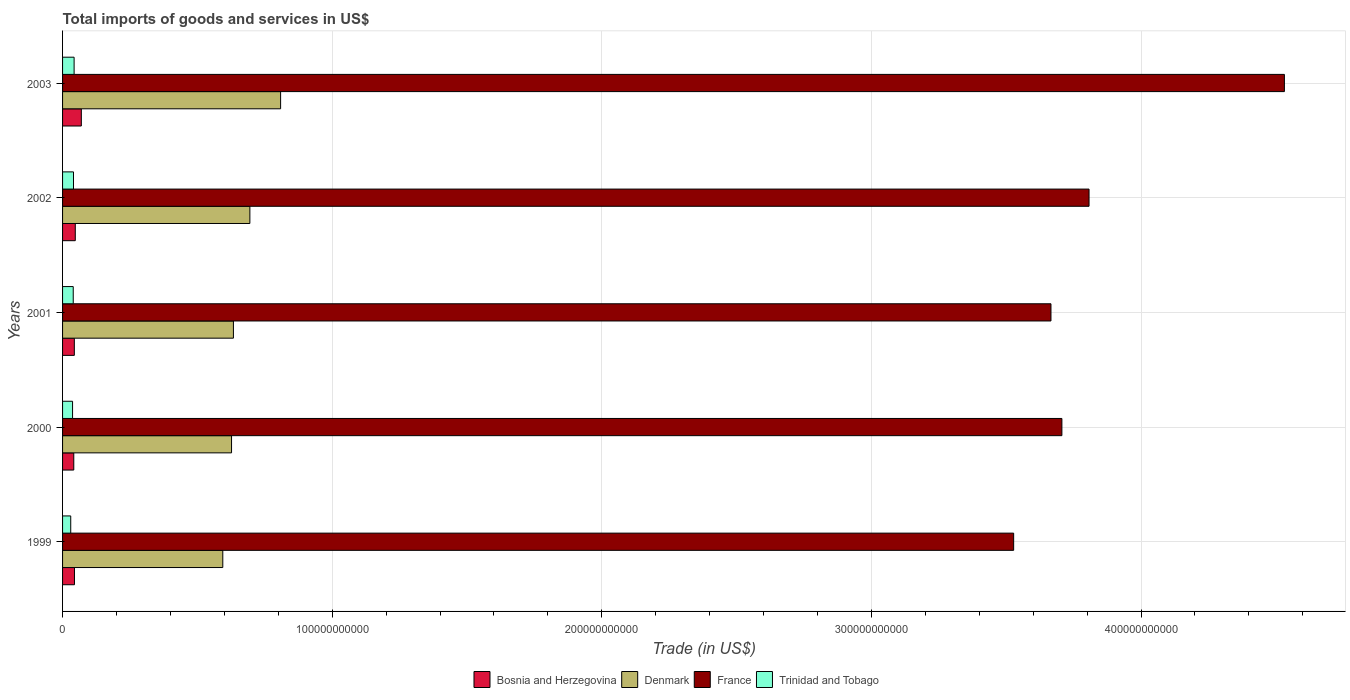How many different coloured bars are there?
Ensure brevity in your answer.  4. How many groups of bars are there?
Provide a succinct answer. 5. Are the number of bars per tick equal to the number of legend labels?
Give a very brief answer. Yes. Are the number of bars on each tick of the Y-axis equal?
Your answer should be very brief. Yes. How many bars are there on the 4th tick from the bottom?
Provide a succinct answer. 4. What is the label of the 2nd group of bars from the top?
Offer a very short reply. 2002. In how many cases, is the number of bars for a given year not equal to the number of legend labels?
Your answer should be very brief. 0. What is the total imports of goods and services in Bosnia and Herzegovina in 2000?
Your answer should be very brief. 4.16e+09. Across all years, what is the maximum total imports of goods and services in Bosnia and Herzegovina?
Ensure brevity in your answer.  6.96e+09. Across all years, what is the minimum total imports of goods and services in Denmark?
Offer a terse response. 5.94e+1. What is the total total imports of goods and services in Trinidad and Tobago in the graph?
Offer a terse response. 1.90e+1. What is the difference between the total imports of goods and services in Denmark in 2000 and that in 2002?
Ensure brevity in your answer.  -6.80e+09. What is the difference between the total imports of goods and services in France in 2000 and the total imports of goods and services in Trinidad and Tobago in 1999?
Make the answer very short. 3.68e+11. What is the average total imports of goods and services in Trinidad and Tobago per year?
Offer a terse response. 3.81e+09. In the year 2001, what is the difference between the total imports of goods and services in Bosnia and Herzegovina and total imports of goods and services in France?
Provide a succinct answer. -3.62e+11. What is the ratio of the total imports of goods and services in France in 1999 to that in 2002?
Provide a short and direct response. 0.93. Is the total imports of goods and services in France in 1999 less than that in 2002?
Offer a very short reply. Yes. What is the difference between the highest and the second highest total imports of goods and services in Trinidad and Tobago?
Offer a terse response. 2.28e+08. What is the difference between the highest and the lowest total imports of goods and services in Trinidad and Tobago?
Offer a very short reply. 1.26e+09. Is the sum of the total imports of goods and services in Denmark in 2000 and 2003 greater than the maximum total imports of goods and services in France across all years?
Provide a short and direct response. No. Is it the case that in every year, the sum of the total imports of goods and services in Bosnia and Herzegovina and total imports of goods and services in France is greater than the sum of total imports of goods and services in Trinidad and Tobago and total imports of goods and services in Denmark?
Give a very brief answer. No. What does the 1st bar from the top in 2003 represents?
Your answer should be compact. Trinidad and Tobago. What does the 4th bar from the bottom in 2003 represents?
Your answer should be very brief. Trinidad and Tobago. Is it the case that in every year, the sum of the total imports of goods and services in Bosnia and Herzegovina and total imports of goods and services in France is greater than the total imports of goods and services in Denmark?
Keep it short and to the point. Yes. How many bars are there?
Your answer should be compact. 20. Are all the bars in the graph horizontal?
Make the answer very short. Yes. What is the difference between two consecutive major ticks on the X-axis?
Your answer should be very brief. 1.00e+11. Are the values on the major ticks of X-axis written in scientific E-notation?
Keep it short and to the point. No. Does the graph contain grids?
Your response must be concise. Yes. Where does the legend appear in the graph?
Ensure brevity in your answer.  Bottom center. How many legend labels are there?
Provide a succinct answer. 4. How are the legend labels stacked?
Make the answer very short. Horizontal. What is the title of the graph?
Your answer should be very brief. Total imports of goods and services in US$. Does "Lower middle income" appear as one of the legend labels in the graph?
Give a very brief answer. No. What is the label or title of the X-axis?
Offer a terse response. Trade (in US$). What is the label or title of the Y-axis?
Keep it short and to the point. Years. What is the Trade (in US$) of Bosnia and Herzegovina in 1999?
Your answer should be very brief. 4.41e+09. What is the Trade (in US$) of Denmark in 1999?
Ensure brevity in your answer.  5.94e+1. What is the Trade (in US$) of France in 1999?
Offer a terse response. 3.53e+11. What is the Trade (in US$) in Trinidad and Tobago in 1999?
Offer a very short reply. 3.03e+09. What is the Trade (in US$) of Bosnia and Herzegovina in 2000?
Ensure brevity in your answer.  4.16e+09. What is the Trade (in US$) of Denmark in 2000?
Keep it short and to the point. 6.27e+1. What is the Trade (in US$) of France in 2000?
Ensure brevity in your answer.  3.71e+11. What is the Trade (in US$) of Trinidad and Tobago in 2000?
Offer a terse response. 3.71e+09. What is the Trade (in US$) in Bosnia and Herzegovina in 2001?
Keep it short and to the point. 4.37e+09. What is the Trade (in US$) of Denmark in 2001?
Provide a short and direct response. 6.34e+1. What is the Trade (in US$) in France in 2001?
Give a very brief answer. 3.67e+11. What is the Trade (in US$) in Trinidad and Tobago in 2001?
Provide a short and direct response. 3.96e+09. What is the Trade (in US$) in Bosnia and Herzegovina in 2002?
Offer a terse response. 4.72e+09. What is the Trade (in US$) in Denmark in 2002?
Offer a very short reply. 6.95e+1. What is the Trade (in US$) of France in 2002?
Offer a very short reply. 3.81e+11. What is the Trade (in US$) in Trinidad and Tobago in 2002?
Provide a short and direct response. 4.06e+09. What is the Trade (in US$) in Bosnia and Herzegovina in 2003?
Provide a succinct answer. 6.96e+09. What is the Trade (in US$) in Denmark in 2003?
Your response must be concise. 8.09e+1. What is the Trade (in US$) of France in 2003?
Provide a succinct answer. 4.53e+11. What is the Trade (in US$) of Trinidad and Tobago in 2003?
Provide a succinct answer. 4.28e+09. Across all years, what is the maximum Trade (in US$) in Bosnia and Herzegovina?
Keep it short and to the point. 6.96e+09. Across all years, what is the maximum Trade (in US$) in Denmark?
Make the answer very short. 8.09e+1. Across all years, what is the maximum Trade (in US$) of France?
Your response must be concise. 4.53e+11. Across all years, what is the maximum Trade (in US$) of Trinidad and Tobago?
Ensure brevity in your answer.  4.28e+09. Across all years, what is the minimum Trade (in US$) of Bosnia and Herzegovina?
Provide a short and direct response. 4.16e+09. Across all years, what is the minimum Trade (in US$) of Denmark?
Make the answer very short. 5.94e+1. Across all years, what is the minimum Trade (in US$) in France?
Provide a short and direct response. 3.53e+11. Across all years, what is the minimum Trade (in US$) in Trinidad and Tobago?
Your answer should be very brief. 3.03e+09. What is the total Trade (in US$) in Bosnia and Herzegovina in the graph?
Your response must be concise. 2.46e+1. What is the total Trade (in US$) in Denmark in the graph?
Provide a short and direct response. 3.36e+11. What is the total Trade (in US$) in France in the graph?
Ensure brevity in your answer.  1.92e+12. What is the total Trade (in US$) of Trinidad and Tobago in the graph?
Provide a succinct answer. 1.90e+1. What is the difference between the Trade (in US$) in Bosnia and Herzegovina in 1999 and that in 2000?
Your answer should be very brief. 2.56e+08. What is the difference between the Trade (in US$) of Denmark in 1999 and that in 2000?
Your response must be concise. -3.24e+09. What is the difference between the Trade (in US$) of France in 1999 and that in 2000?
Your answer should be compact. -1.79e+1. What is the difference between the Trade (in US$) of Trinidad and Tobago in 1999 and that in 2000?
Your answer should be compact. -6.83e+08. What is the difference between the Trade (in US$) of Bosnia and Herzegovina in 1999 and that in 2001?
Give a very brief answer. 4.79e+07. What is the difference between the Trade (in US$) of Denmark in 1999 and that in 2001?
Make the answer very short. -3.94e+09. What is the difference between the Trade (in US$) in France in 1999 and that in 2001?
Offer a very short reply. -1.38e+1. What is the difference between the Trade (in US$) in Trinidad and Tobago in 1999 and that in 2001?
Your response must be concise. -9.30e+08. What is the difference between the Trade (in US$) of Bosnia and Herzegovina in 1999 and that in 2002?
Ensure brevity in your answer.  -3.05e+08. What is the difference between the Trade (in US$) in Denmark in 1999 and that in 2002?
Ensure brevity in your answer.  -1.00e+1. What is the difference between the Trade (in US$) in France in 1999 and that in 2002?
Provide a short and direct response. -2.80e+1. What is the difference between the Trade (in US$) of Trinidad and Tobago in 1999 and that in 2002?
Offer a very short reply. -1.03e+09. What is the difference between the Trade (in US$) of Bosnia and Herzegovina in 1999 and that in 2003?
Offer a very short reply. -2.55e+09. What is the difference between the Trade (in US$) of Denmark in 1999 and that in 2003?
Provide a succinct answer. -2.14e+1. What is the difference between the Trade (in US$) in France in 1999 and that in 2003?
Offer a very short reply. -1.00e+11. What is the difference between the Trade (in US$) in Trinidad and Tobago in 1999 and that in 2003?
Provide a succinct answer. -1.26e+09. What is the difference between the Trade (in US$) in Bosnia and Herzegovina in 2000 and that in 2001?
Provide a short and direct response. -2.08e+08. What is the difference between the Trade (in US$) in Denmark in 2000 and that in 2001?
Give a very brief answer. -6.96e+08. What is the difference between the Trade (in US$) of France in 2000 and that in 2001?
Provide a short and direct response. 4.06e+09. What is the difference between the Trade (in US$) in Trinidad and Tobago in 2000 and that in 2001?
Offer a terse response. -2.47e+08. What is the difference between the Trade (in US$) of Bosnia and Herzegovina in 2000 and that in 2002?
Keep it short and to the point. -5.61e+08. What is the difference between the Trade (in US$) of Denmark in 2000 and that in 2002?
Your response must be concise. -6.80e+09. What is the difference between the Trade (in US$) of France in 2000 and that in 2002?
Your answer should be very brief. -1.01e+1. What is the difference between the Trade (in US$) in Trinidad and Tobago in 2000 and that in 2002?
Ensure brevity in your answer.  -3.45e+08. What is the difference between the Trade (in US$) of Bosnia and Herzegovina in 2000 and that in 2003?
Ensure brevity in your answer.  -2.80e+09. What is the difference between the Trade (in US$) in Denmark in 2000 and that in 2003?
Your answer should be very brief. -1.82e+1. What is the difference between the Trade (in US$) in France in 2000 and that in 2003?
Offer a very short reply. -8.25e+1. What is the difference between the Trade (in US$) of Trinidad and Tobago in 2000 and that in 2003?
Provide a short and direct response. -5.74e+08. What is the difference between the Trade (in US$) of Bosnia and Herzegovina in 2001 and that in 2002?
Give a very brief answer. -3.53e+08. What is the difference between the Trade (in US$) in Denmark in 2001 and that in 2002?
Make the answer very short. -6.10e+09. What is the difference between the Trade (in US$) in France in 2001 and that in 2002?
Keep it short and to the point. -1.41e+1. What is the difference between the Trade (in US$) of Trinidad and Tobago in 2001 and that in 2002?
Offer a terse response. -9.82e+07. What is the difference between the Trade (in US$) in Bosnia and Herzegovina in 2001 and that in 2003?
Your answer should be very brief. -2.60e+09. What is the difference between the Trade (in US$) in Denmark in 2001 and that in 2003?
Provide a short and direct response. -1.75e+1. What is the difference between the Trade (in US$) in France in 2001 and that in 2003?
Make the answer very short. -8.66e+1. What is the difference between the Trade (in US$) in Trinidad and Tobago in 2001 and that in 2003?
Provide a succinct answer. -3.26e+08. What is the difference between the Trade (in US$) of Bosnia and Herzegovina in 2002 and that in 2003?
Provide a short and direct response. -2.24e+09. What is the difference between the Trade (in US$) of Denmark in 2002 and that in 2003?
Your answer should be very brief. -1.14e+1. What is the difference between the Trade (in US$) of France in 2002 and that in 2003?
Give a very brief answer. -7.25e+1. What is the difference between the Trade (in US$) in Trinidad and Tobago in 2002 and that in 2003?
Give a very brief answer. -2.28e+08. What is the difference between the Trade (in US$) in Bosnia and Herzegovina in 1999 and the Trade (in US$) in Denmark in 2000?
Ensure brevity in your answer.  -5.83e+1. What is the difference between the Trade (in US$) in Bosnia and Herzegovina in 1999 and the Trade (in US$) in France in 2000?
Your answer should be compact. -3.66e+11. What is the difference between the Trade (in US$) in Bosnia and Herzegovina in 1999 and the Trade (in US$) in Trinidad and Tobago in 2000?
Give a very brief answer. 7.03e+08. What is the difference between the Trade (in US$) in Denmark in 1999 and the Trade (in US$) in France in 2000?
Make the answer very short. -3.11e+11. What is the difference between the Trade (in US$) of Denmark in 1999 and the Trade (in US$) of Trinidad and Tobago in 2000?
Your answer should be very brief. 5.57e+1. What is the difference between the Trade (in US$) of France in 1999 and the Trade (in US$) of Trinidad and Tobago in 2000?
Give a very brief answer. 3.49e+11. What is the difference between the Trade (in US$) in Bosnia and Herzegovina in 1999 and the Trade (in US$) in Denmark in 2001?
Ensure brevity in your answer.  -5.90e+1. What is the difference between the Trade (in US$) of Bosnia and Herzegovina in 1999 and the Trade (in US$) of France in 2001?
Ensure brevity in your answer.  -3.62e+11. What is the difference between the Trade (in US$) in Bosnia and Herzegovina in 1999 and the Trade (in US$) in Trinidad and Tobago in 2001?
Make the answer very short. 4.56e+08. What is the difference between the Trade (in US$) in Denmark in 1999 and the Trade (in US$) in France in 2001?
Ensure brevity in your answer.  -3.07e+11. What is the difference between the Trade (in US$) in Denmark in 1999 and the Trade (in US$) in Trinidad and Tobago in 2001?
Provide a succinct answer. 5.55e+1. What is the difference between the Trade (in US$) in France in 1999 and the Trade (in US$) in Trinidad and Tobago in 2001?
Give a very brief answer. 3.49e+11. What is the difference between the Trade (in US$) of Bosnia and Herzegovina in 1999 and the Trade (in US$) of Denmark in 2002?
Ensure brevity in your answer.  -6.51e+1. What is the difference between the Trade (in US$) of Bosnia and Herzegovina in 1999 and the Trade (in US$) of France in 2002?
Keep it short and to the point. -3.76e+11. What is the difference between the Trade (in US$) in Bosnia and Herzegovina in 1999 and the Trade (in US$) in Trinidad and Tobago in 2002?
Offer a terse response. 3.58e+08. What is the difference between the Trade (in US$) of Denmark in 1999 and the Trade (in US$) of France in 2002?
Your answer should be compact. -3.21e+11. What is the difference between the Trade (in US$) of Denmark in 1999 and the Trade (in US$) of Trinidad and Tobago in 2002?
Offer a very short reply. 5.54e+1. What is the difference between the Trade (in US$) in France in 1999 and the Trade (in US$) in Trinidad and Tobago in 2002?
Provide a short and direct response. 3.49e+11. What is the difference between the Trade (in US$) in Bosnia and Herzegovina in 1999 and the Trade (in US$) in Denmark in 2003?
Give a very brief answer. -7.65e+1. What is the difference between the Trade (in US$) in Bosnia and Herzegovina in 1999 and the Trade (in US$) in France in 2003?
Provide a succinct answer. -4.49e+11. What is the difference between the Trade (in US$) in Bosnia and Herzegovina in 1999 and the Trade (in US$) in Trinidad and Tobago in 2003?
Your answer should be very brief. 1.30e+08. What is the difference between the Trade (in US$) of Denmark in 1999 and the Trade (in US$) of France in 2003?
Provide a succinct answer. -3.94e+11. What is the difference between the Trade (in US$) of Denmark in 1999 and the Trade (in US$) of Trinidad and Tobago in 2003?
Provide a succinct answer. 5.51e+1. What is the difference between the Trade (in US$) of France in 1999 and the Trade (in US$) of Trinidad and Tobago in 2003?
Offer a very short reply. 3.48e+11. What is the difference between the Trade (in US$) of Bosnia and Herzegovina in 2000 and the Trade (in US$) of Denmark in 2001?
Keep it short and to the point. -5.92e+1. What is the difference between the Trade (in US$) in Bosnia and Herzegovina in 2000 and the Trade (in US$) in France in 2001?
Ensure brevity in your answer.  -3.62e+11. What is the difference between the Trade (in US$) of Bosnia and Herzegovina in 2000 and the Trade (in US$) of Trinidad and Tobago in 2001?
Provide a succinct answer. 2.00e+08. What is the difference between the Trade (in US$) in Denmark in 2000 and the Trade (in US$) in France in 2001?
Your response must be concise. -3.04e+11. What is the difference between the Trade (in US$) in Denmark in 2000 and the Trade (in US$) in Trinidad and Tobago in 2001?
Offer a terse response. 5.87e+1. What is the difference between the Trade (in US$) in France in 2000 and the Trade (in US$) in Trinidad and Tobago in 2001?
Your answer should be very brief. 3.67e+11. What is the difference between the Trade (in US$) in Bosnia and Herzegovina in 2000 and the Trade (in US$) in Denmark in 2002?
Ensure brevity in your answer.  -6.53e+1. What is the difference between the Trade (in US$) of Bosnia and Herzegovina in 2000 and the Trade (in US$) of France in 2002?
Your response must be concise. -3.77e+11. What is the difference between the Trade (in US$) of Bosnia and Herzegovina in 2000 and the Trade (in US$) of Trinidad and Tobago in 2002?
Provide a short and direct response. 1.02e+08. What is the difference between the Trade (in US$) in Denmark in 2000 and the Trade (in US$) in France in 2002?
Make the answer very short. -3.18e+11. What is the difference between the Trade (in US$) of Denmark in 2000 and the Trade (in US$) of Trinidad and Tobago in 2002?
Provide a succinct answer. 5.86e+1. What is the difference between the Trade (in US$) of France in 2000 and the Trade (in US$) of Trinidad and Tobago in 2002?
Offer a very short reply. 3.67e+11. What is the difference between the Trade (in US$) of Bosnia and Herzegovina in 2000 and the Trade (in US$) of Denmark in 2003?
Provide a succinct answer. -7.67e+1. What is the difference between the Trade (in US$) of Bosnia and Herzegovina in 2000 and the Trade (in US$) of France in 2003?
Provide a succinct answer. -4.49e+11. What is the difference between the Trade (in US$) of Bosnia and Herzegovina in 2000 and the Trade (in US$) of Trinidad and Tobago in 2003?
Your answer should be compact. -1.26e+08. What is the difference between the Trade (in US$) in Denmark in 2000 and the Trade (in US$) in France in 2003?
Provide a succinct answer. -3.91e+11. What is the difference between the Trade (in US$) of Denmark in 2000 and the Trade (in US$) of Trinidad and Tobago in 2003?
Your answer should be compact. 5.84e+1. What is the difference between the Trade (in US$) in France in 2000 and the Trade (in US$) in Trinidad and Tobago in 2003?
Give a very brief answer. 3.66e+11. What is the difference between the Trade (in US$) of Bosnia and Herzegovina in 2001 and the Trade (in US$) of Denmark in 2002?
Your answer should be compact. -6.51e+1. What is the difference between the Trade (in US$) of Bosnia and Herzegovina in 2001 and the Trade (in US$) of France in 2002?
Keep it short and to the point. -3.76e+11. What is the difference between the Trade (in US$) of Bosnia and Herzegovina in 2001 and the Trade (in US$) of Trinidad and Tobago in 2002?
Give a very brief answer. 3.10e+08. What is the difference between the Trade (in US$) in Denmark in 2001 and the Trade (in US$) in France in 2002?
Provide a succinct answer. -3.17e+11. What is the difference between the Trade (in US$) in Denmark in 2001 and the Trade (in US$) in Trinidad and Tobago in 2002?
Ensure brevity in your answer.  5.93e+1. What is the difference between the Trade (in US$) of France in 2001 and the Trade (in US$) of Trinidad and Tobago in 2002?
Keep it short and to the point. 3.63e+11. What is the difference between the Trade (in US$) in Bosnia and Herzegovina in 2001 and the Trade (in US$) in Denmark in 2003?
Your response must be concise. -7.65e+1. What is the difference between the Trade (in US$) in Bosnia and Herzegovina in 2001 and the Trade (in US$) in France in 2003?
Offer a very short reply. -4.49e+11. What is the difference between the Trade (in US$) of Bosnia and Herzegovina in 2001 and the Trade (in US$) of Trinidad and Tobago in 2003?
Your answer should be very brief. 8.17e+07. What is the difference between the Trade (in US$) in Denmark in 2001 and the Trade (in US$) in France in 2003?
Keep it short and to the point. -3.90e+11. What is the difference between the Trade (in US$) in Denmark in 2001 and the Trade (in US$) in Trinidad and Tobago in 2003?
Provide a succinct answer. 5.91e+1. What is the difference between the Trade (in US$) in France in 2001 and the Trade (in US$) in Trinidad and Tobago in 2003?
Ensure brevity in your answer.  3.62e+11. What is the difference between the Trade (in US$) of Bosnia and Herzegovina in 2002 and the Trade (in US$) of Denmark in 2003?
Ensure brevity in your answer.  -7.62e+1. What is the difference between the Trade (in US$) in Bosnia and Herzegovina in 2002 and the Trade (in US$) in France in 2003?
Your answer should be compact. -4.48e+11. What is the difference between the Trade (in US$) of Bosnia and Herzegovina in 2002 and the Trade (in US$) of Trinidad and Tobago in 2003?
Provide a short and direct response. 4.34e+08. What is the difference between the Trade (in US$) in Denmark in 2002 and the Trade (in US$) in France in 2003?
Offer a terse response. -3.84e+11. What is the difference between the Trade (in US$) of Denmark in 2002 and the Trade (in US$) of Trinidad and Tobago in 2003?
Your response must be concise. 6.52e+1. What is the difference between the Trade (in US$) in France in 2002 and the Trade (in US$) in Trinidad and Tobago in 2003?
Offer a terse response. 3.76e+11. What is the average Trade (in US$) in Bosnia and Herzegovina per year?
Your answer should be compact. 4.92e+09. What is the average Trade (in US$) in Denmark per year?
Your answer should be compact. 6.72e+1. What is the average Trade (in US$) in France per year?
Offer a terse response. 3.85e+11. What is the average Trade (in US$) in Trinidad and Tobago per year?
Provide a succinct answer. 3.81e+09. In the year 1999, what is the difference between the Trade (in US$) of Bosnia and Herzegovina and Trade (in US$) of Denmark?
Make the answer very short. -5.50e+1. In the year 1999, what is the difference between the Trade (in US$) of Bosnia and Herzegovina and Trade (in US$) of France?
Provide a short and direct response. -3.48e+11. In the year 1999, what is the difference between the Trade (in US$) of Bosnia and Herzegovina and Trade (in US$) of Trinidad and Tobago?
Provide a succinct answer. 1.39e+09. In the year 1999, what is the difference between the Trade (in US$) in Denmark and Trade (in US$) in France?
Your answer should be compact. -2.93e+11. In the year 1999, what is the difference between the Trade (in US$) in Denmark and Trade (in US$) in Trinidad and Tobago?
Your answer should be compact. 5.64e+1. In the year 1999, what is the difference between the Trade (in US$) of France and Trade (in US$) of Trinidad and Tobago?
Provide a short and direct response. 3.50e+11. In the year 2000, what is the difference between the Trade (in US$) of Bosnia and Herzegovina and Trade (in US$) of Denmark?
Your answer should be compact. -5.85e+1. In the year 2000, what is the difference between the Trade (in US$) of Bosnia and Herzegovina and Trade (in US$) of France?
Offer a terse response. -3.66e+11. In the year 2000, what is the difference between the Trade (in US$) in Bosnia and Herzegovina and Trade (in US$) in Trinidad and Tobago?
Give a very brief answer. 4.47e+08. In the year 2000, what is the difference between the Trade (in US$) in Denmark and Trade (in US$) in France?
Provide a short and direct response. -3.08e+11. In the year 2000, what is the difference between the Trade (in US$) in Denmark and Trade (in US$) in Trinidad and Tobago?
Provide a succinct answer. 5.90e+1. In the year 2000, what is the difference between the Trade (in US$) in France and Trade (in US$) in Trinidad and Tobago?
Ensure brevity in your answer.  3.67e+11. In the year 2001, what is the difference between the Trade (in US$) of Bosnia and Herzegovina and Trade (in US$) of Denmark?
Give a very brief answer. -5.90e+1. In the year 2001, what is the difference between the Trade (in US$) in Bosnia and Herzegovina and Trade (in US$) in France?
Offer a terse response. -3.62e+11. In the year 2001, what is the difference between the Trade (in US$) of Bosnia and Herzegovina and Trade (in US$) of Trinidad and Tobago?
Make the answer very short. 4.08e+08. In the year 2001, what is the difference between the Trade (in US$) in Denmark and Trade (in US$) in France?
Offer a very short reply. -3.03e+11. In the year 2001, what is the difference between the Trade (in US$) of Denmark and Trade (in US$) of Trinidad and Tobago?
Offer a terse response. 5.94e+1. In the year 2001, what is the difference between the Trade (in US$) of France and Trade (in US$) of Trinidad and Tobago?
Make the answer very short. 3.63e+11. In the year 2002, what is the difference between the Trade (in US$) of Bosnia and Herzegovina and Trade (in US$) of Denmark?
Make the answer very short. -6.48e+1. In the year 2002, what is the difference between the Trade (in US$) of Bosnia and Herzegovina and Trade (in US$) of France?
Ensure brevity in your answer.  -3.76e+11. In the year 2002, what is the difference between the Trade (in US$) of Bosnia and Herzegovina and Trade (in US$) of Trinidad and Tobago?
Offer a terse response. 6.62e+08. In the year 2002, what is the difference between the Trade (in US$) in Denmark and Trade (in US$) in France?
Make the answer very short. -3.11e+11. In the year 2002, what is the difference between the Trade (in US$) in Denmark and Trade (in US$) in Trinidad and Tobago?
Make the answer very short. 6.54e+1. In the year 2002, what is the difference between the Trade (in US$) in France and Trade (in US$) in Trinidad and Tobago?
Provide a short and direct response. 3.77e+11. In the year 2003, what is the difference between the Trade (in US$) in Bosnia and Herzegovina and Trade (in US$) in Denmark?
Make the answer very short. -7.39e+1. In the year 2003, what is the difference between the Trade (in US$) in Bosnia and Herzegovina and Trade (in US$) in France?
Provide a succinct answer. -4.46e+11. In the year 2003, what is the difference between the Trade (in US$) of Bosnia and Herzegovina and Trade (in US$) of Trinidad and Tobago?
Ensure brevity in your answer.  2.68e+09. In the year 2003, what is the difference between the Trade (in US$) of Denmark and Trade (in US$) of France?
Offer a terse response. -3.72e+11. In the year 2003, what is the difference between the Trade (in US$) of Denmark and Trade (in US$) of Trinidad and Tobago?
Ensure brevity in your answer.  7.66e+1. In the year 2003, what is the difference between the Trade (in US$) of France and Trade (in US$) of Trinidad and Tobago?
Offer a terse response. 4.49e+11. What is the ratio of the Trade (in US$) of Bosnia and Herzegovina in 1999 to that in 2000?
Your response must be concise. 1.06. What is the ratio of the Trade (in US$) of Denmark in 1999 to that in 2000?
Give a very brief answer. 0.95. What is the ratio of the Trade (in US$) in France in 1999 to that in 2000?
Your response must be concise. 0.95. What is the ratio of the Trade (in US$) of Trinidad and Tobago in 1999 to that in 2000?
Offer a very short reply. 0.82. What is the ratio of the Trade (in US$) of Denmark in 1999 to that in 2001?
Give a very brief answer. 0.94. What is the ratio of the Trade (in US$) in France in 1999 to that in 2001?
Provide a succinct answer. 0.96. What is the ratio of the Trade (in US$) of Trinidad and Tobago in 1999 to that in 2001?
Offer a terse response. 0.77. What is the ratio of the Trade (in US$) of Bosnia and Herzegovina in 1999 to that in 2002?
Provide a succinct answer. 0.94. What is the ratio of the Trade (in US$) in Denmark in 1999 to that in 2002?
Keep it short and to the point. 0.86. What is the ratio of the Trade (in US$) in France in 1999 to that in 2002?
Your response must be concise. 0.93. What is the ratio of the Trade (in US$) in Trinidad and Tobago in 1999 to that in 2002?
Provide a short and direct response. 0.75. What is the ratio of the Trade (in US$) of Bosnia and Herzegovina in 1999 to that in 2003?
Give a very brief answer. 0.63. What is the ratio of the Trade (in US$) in Denmark in 1999 to that in 2003?
Ensure brevity in your answer.  0.73. What is the ratio of the Trade (in US$) in France in 1999 to that in 2003?
Offer a terse response. 0.78. What is the ratio of the Trade (in US$) in Trinidad and Tobago in 1999 to that in 2003?
Your answer should be very brief. 0.71. What is the ratio of the Trade (in US$) of France in 2000 to that in 2001?
Give a very brief answer. 1.01. What is the ratio of the Trade (in US$) of Trinidad and Tobago in 2000 to that in 2001?
Ensure brevity in your answer.  0.94. What is the ratio of the Trade (in US$) in Bosnia and Herzegovina in 2000 to that in 2002?
Your answer should be compact. 0.88. What is the ratio of the Trade (in US$) of Denmark in 2000 to that in 2002?
Your answer should be compact. 0.9. What is the ratio of the Trade (in US$) of France in 2000 to that in 2002?
Provide a short and direct response. 0.97. What is the ratio of the Trade (in US$) in Trinidad and Tobago in 2000 to that in 2002?
Offer a terse response. 0.91. What is the ratio of the Trade (in US$) in Bosnia and Herzegovina in 2000 to that in 2003?
Offer a terse response. 0.6. What is the ratio of the Trade (in US$) of Denmark in 2000 to that in 2003?
Give a very brief answer. 0.77. What is the ratio of the Trade (in US$) in France in 2000 to that in 2003?
Your answer should be very brief. 0.82. What is the ratio of the Trade (in US$) of Trinidad and Tobago in 2000 to that in 2003?
Keep it short and to the point. 0.87. What is the ratio of the Trade (in US$) of Bosnia and Herzegovina in 2001 to that in 2002?
Provide a short and direct response. 0.93. What is the ratio of the Trade (in US$) of Denmark in 2001 to that in 2002?
Provide a succinct answer. 0.91. What is the ratio of the Trade (in US$) of France in 2001 to that in 2002?
Make the answer very short. 0.96. What is the ratio of the Trade (in US$) of Trinidad and Tobago in 2001 to that in 2002?
Make the answer very short. 0.98. What is the ratio of the Trade (in US$) of Bosnia and Herzegovina in 2001 to that in 2003?
Provide a short and direct response. 0.63. What is the ratio of the Trade (in US$) in Denmark in 2001 to that in 2003?
Offer a terse response. 0.78. What is the ratio of the Trade (in US$) of France in 2001 to that in 2003?
Give a very brief answer. 0.81. What is the ratio of the Trade (in US$) of Trinidad and Tobago in 2001 to that in 2003?
Make the answer very short. 0.92. What is the ratio of the Trade (in US$) in Bosnia and Herzegovina in 2002 to that in 2003?
Offer a terse response. 0.68. What is the ratio of the Trade (in US$) of Denmark in 2002 to that in 2003?
Your response must be concise. 0.86. What is the ratio of the Trade (in US$) of France in 2002 to that in 2003?
Give a very brief answer. 0.84. What is the ratio of the Trade (in US$) of Trinidad and Tobago in 2002 to that in 2003?
Offer a terse response. 0.95. What is the difference between the highest and the second highest Trade (in US$) in Bosnia and Herzegovina?
Make the answer very short. 2.24e+09. What is the difference between the highest and the second highest Trade (in US$) of Denmark?
Ensure brevity in your answer.  1.14e+1. What is the difference between the highest and the second highest Trade (in US$) of France?
Give a very brief answer. 7.25e+1. What is the difference between the highest and the second highest Trade (in US$) in Trinidad and Tobago?
Keep it short and to the point. 2.28e+08. What is the difference between the highest and the lowest Trade (in US$) of Bosnia and Herzegovina?
Make the answer very short. 2.80e+09. What is the difference between the highest and the lowest Trade (in US$) of Denmark?
Offer a terse response. 2.14e+1. What is the difference between the highest and the lowest Trade (in US$) of France?
Your response must be concise. 1.00e+11. What is the difference between the highest and the lowest Trade (in US$) of Trinidad and Tobago?
Your response must be concise. 1.26e+09. 